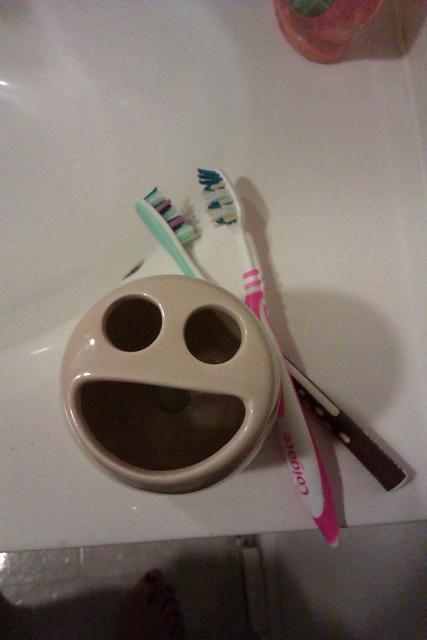How many toothbrushes are in the picture?
Give a very brief answer. 2. How many sinks are there?
Give a very brief answer. 1. How many toothbrushes are there?
Give a very brief answer. 2. How many bears are standing near the waterfalls?
Give a very brief answer. 0. 